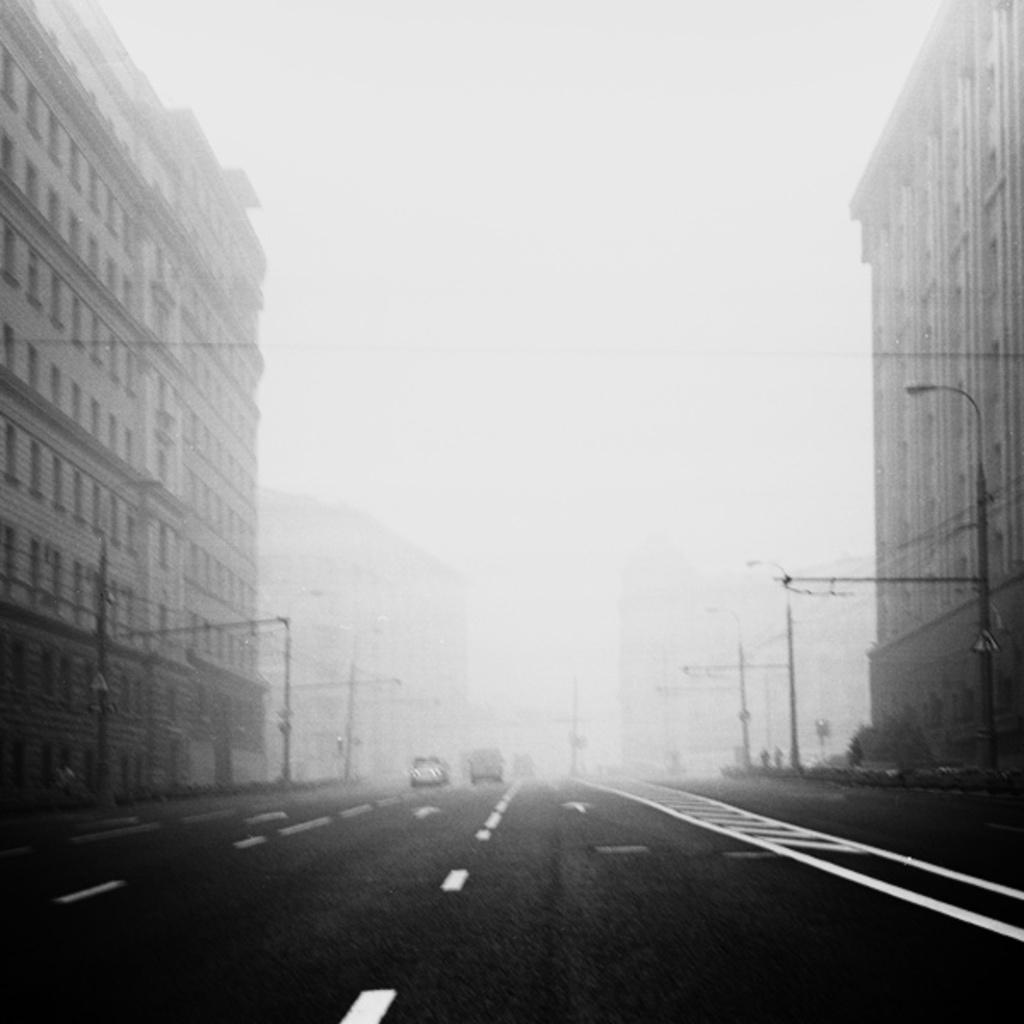How would you summarize this image in a sentence or two? In the center of the image there are vehicles on the road. On both right and left side of the image there are street lights, boards, buildings. In the background of the image there is sky. 